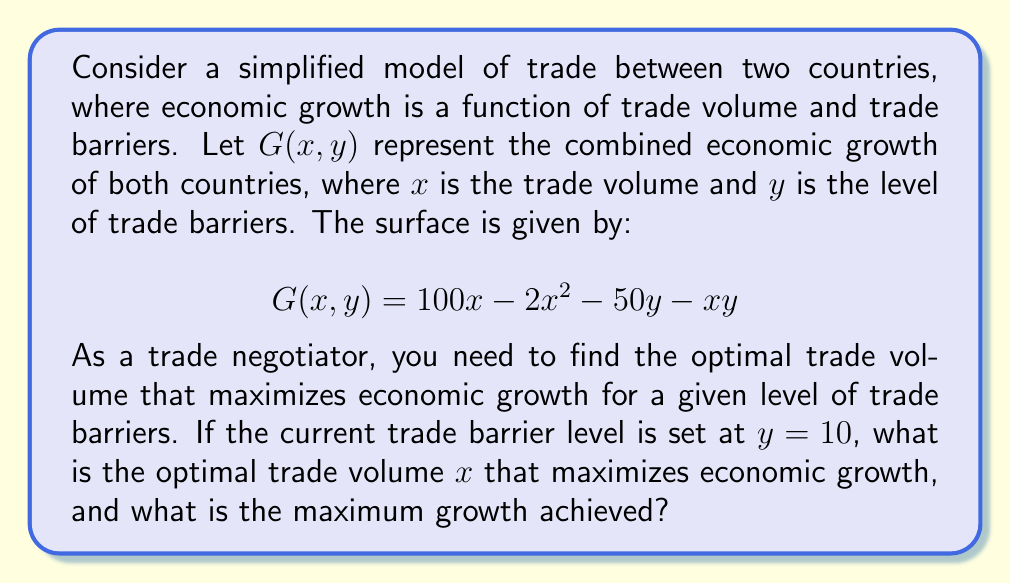Give your solution to this math problem. To solve this problem, we'll follow these steps:

1) First, we need to find the partial derivative of $G$ with respect to $x$:

   $$\frac{\partial G}{\partial x} = 100 - 4x - y$$

2) To find the maximum, we set this equal to zero and solve for $x$:

   $$100 - 4x - y = 0$$
   $$100 - y = 4x$$
   $$x = \frac{100 - y}{4}$$

3) This gives us the optimal $x$ for any given $y$. We're told that $y = 10$, so let's substitute this:

   $$x = \frac{100 - 10}{4} = \frac{90}{4} = 22.5$$

4) To find the maximum growth achieved, we substitute $x = 22.5$ and $y = 10$ into our original function:

   $$G(22.5, 10) = 100(22.5) - 2(22.5)^2 - 50(10) - 22.5(10)$$
   
   $$= 2250 - 1012.5 - 500 - 225$$
   
   $$= 512.5$$

Therefore, the optimal trade volume is 22.5 units, and the maximum economic growth achieved is 512.5 units.
Answer: Optimal trade volume: $x = 22.5$; Maximum growth: $G = 512.5$ 